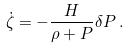<formula> <loc_0><loc_0><loc_500><loc_500>\dot { \zeta } = - \frac { H } { \rho + P } \delta P \, .</formula> 